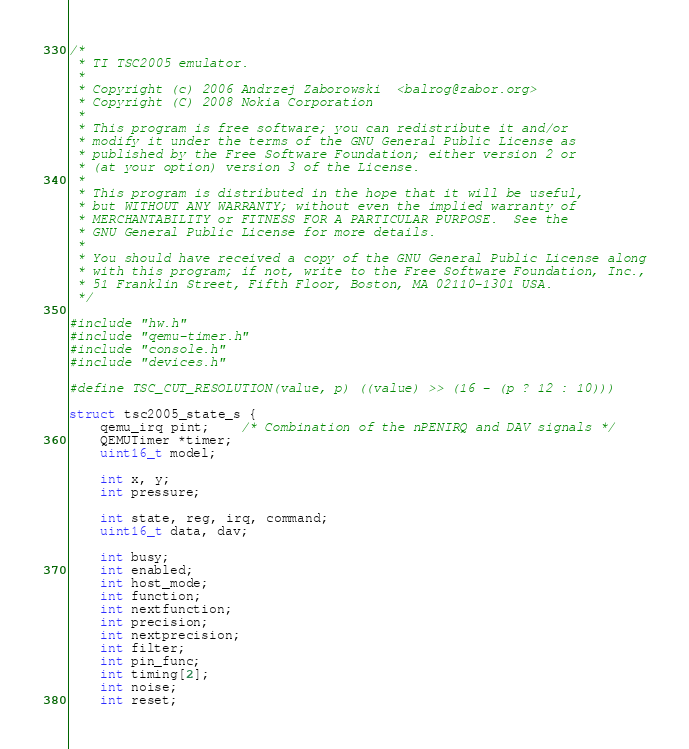<code> <loc_0><loc_0><loc_500><loc_500><_C_>/*
 * TI TSC2005 emulator.
 *
 * Copyright (c) 2006 Andrzej Zaborowski  <balrog@zabor.org>
 * Copyright (C) 2008 Nokia Corporation
 *
 * This program is free software; you can redistribute it and/or
 * modify it under the terms of the GNU General Public License as
 * published by the Free Software Foundation; either version 2 or
 * (at your option) version 3 of the License.
 *
 * This program is distributed in the hope that it will be useful,
 * but WITHOUT ANY WARRANTY; without even the implied warranty of
 * MERCHANTABILITY or FITNESS FOR A PARTICULAR PURPOSE.  See the
 * GNU General Public License for more details.
 *
 * You should have received a copy of the GNU General Public License along
 * with this program; if not, write to the Free Software Foundation, Inc.,
 * 51 Franklin Street, Fifth Floor, Boston, MA 02110-1301 USA.
 */

#include "hw.h"
#include "qemu-timer.h"
#include "console.h"
#include "devices.h"

#define TSC_CUT_RESOLUTION(value, p)	((value) >> (16 - (p ? 12 : 10)))

struct tsc2005_state_s {
    qemu_irq pint;	/* Combination of the nPENIRQ and DAV signals */
    QEMUTimer *timer;
    uint16_t model;

    int x, y;
    int pressure;

    int state, reg, irq, command;
    uint16_t data, dav;

    int busy;
    int enabled;
    int host_mode;
    int function;
    int nextfunction;
    int precision;
    int nextprecision;
    int filter;
    int pin_func;
    int timing[2];
    int noise;
    int reset;</code> 